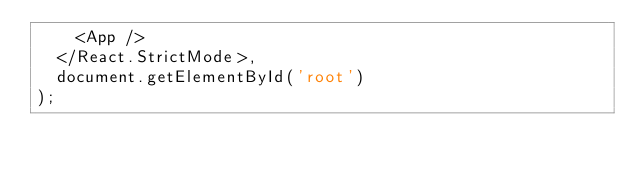<code> <loc_0><loc_0><loc_500><loc_500><_JavaScript_>    <App />
  </React.StrictMode>,
  document.getElementById('root')
);

</code> 